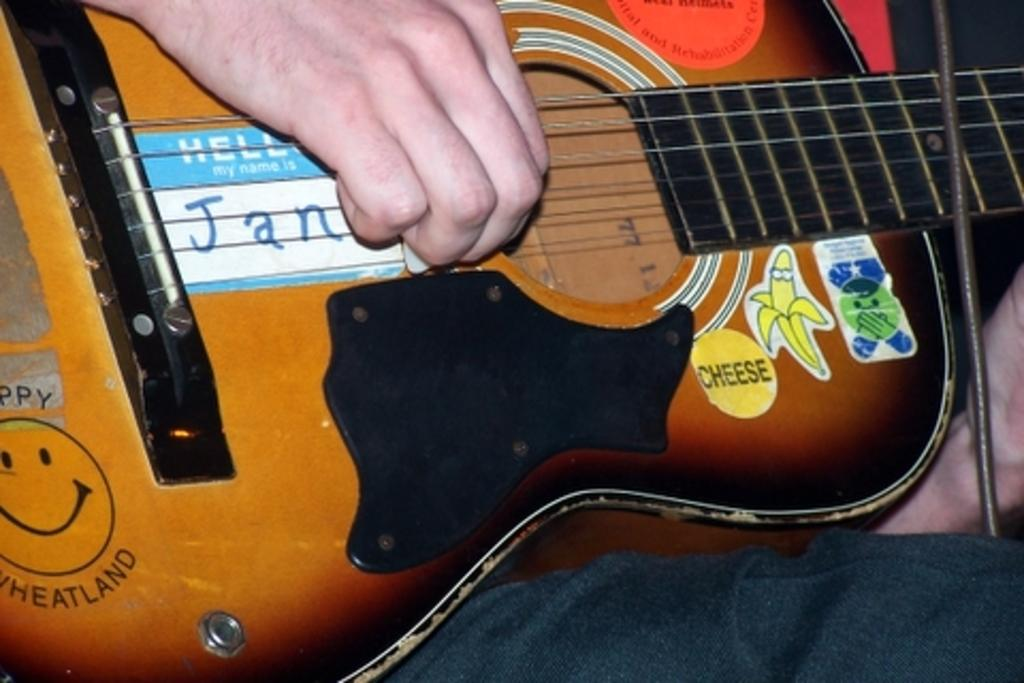What can be seen in the image related to a musical instrument? There are human hands in the image holding a guitar. What is the color of the guitar being held? The guitar is brown in color. Is there any text present on the guitar? Yes, there is text written on the guitar. What type of celery is being used as a chess piece in the image? There is no celery or chess pieces present in the image. 